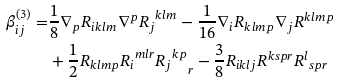Convert formula to latex. <formula><loc_0><loc_0><loc_500><loc_500>\beta ^ { ( 3 ) } _ { i j } = & \frac { 1 } { 8 } \nabla _ { p } R _ { i k l m } \nabla ^ { p } { R _ { j } } ^ { k l m } - \frac { 1 } { 1 6 } \nabla _ { i } R _ { k l m p } \nabla _ { j } R ^ { k l m p } \\ & + \frac { 1 } { 2 } R _ { k l m p } { R _ { i } } ^ { m l r } { { R _ { j } } ^ { k p } } _ { r } - \frac { 3 } { 8 } R _ { i k l j } R ^ { k s p r } { R ^ { l } } _ { s p r }</formula> 